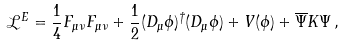<formula> <loc_0><loc_0><loc_500><loc_500>\mathcal { L } ^ { E } = \frac { 1 } { 4 } F _ { \mu \nu } F _ { \mu \nu } + \frac { 1 } { 2 } ( D _ { \mu } \phi ) ^ { \dagger } ( D _ { \mu } \phi ) + V ( \phi ) + \overline { \Psi } K \Psi \, ,</formula> 